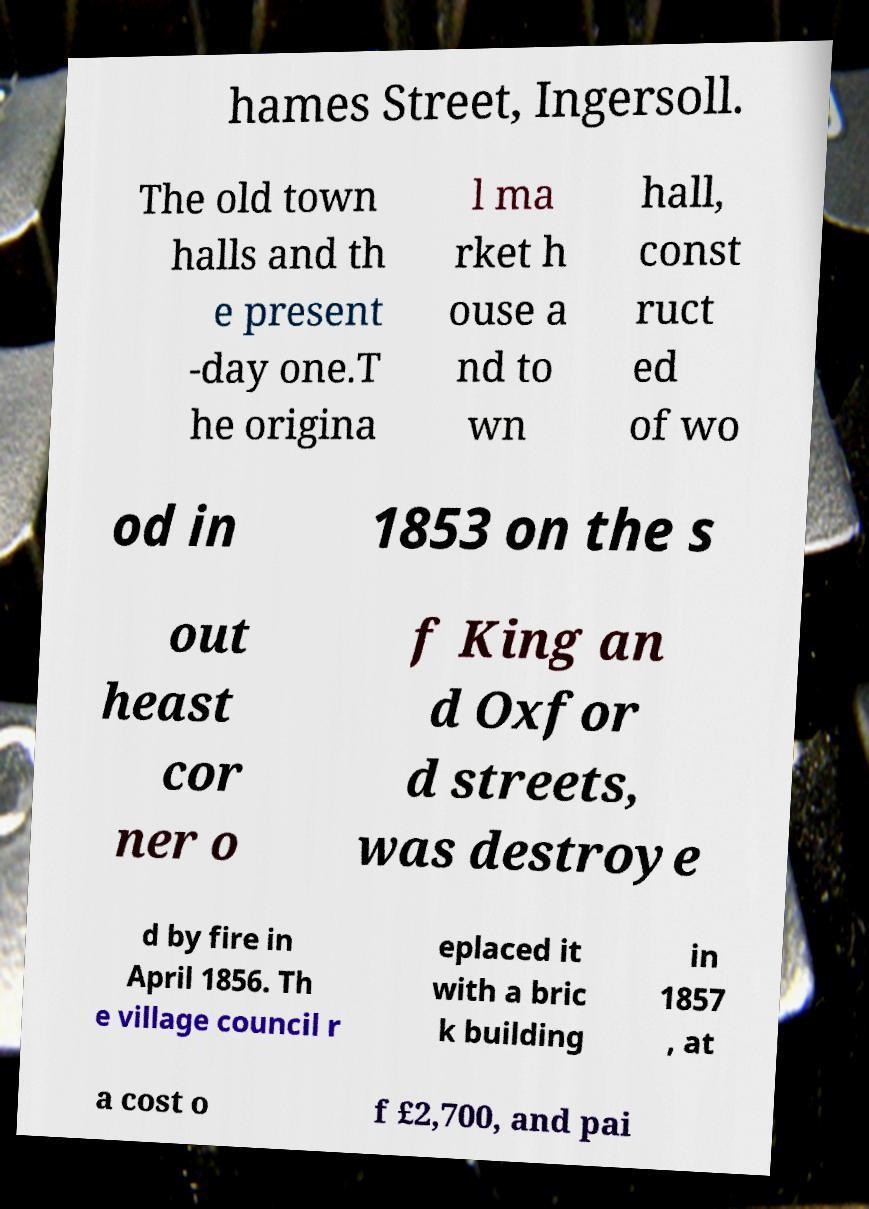For documentation purposes, I need the text within this image transcribed. Could you provide that? hames Street, Ingersoll. The old town halls and th e present -day one.T he origina l ma rket h ouse a nd to wn hall, const ruct ed of wo od in 1853 on the s out heast cor ner o f King an d Oxfor d streets, was destroye d by fire in April 1856. Th e village council r eplaced it with a bric k building in 1857 , at a cost o f £2,700, and pai 